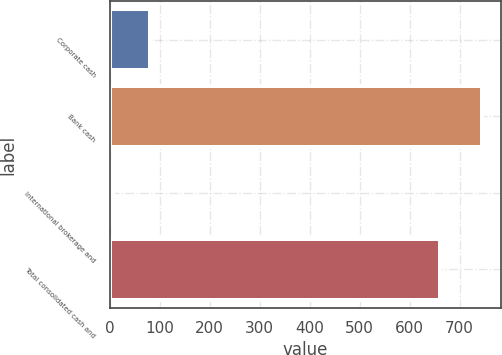Convert chart. <chart><loc_0><loc_0><loc_500><loc_500><bar_chart><fcel>Corporate cash<fcel>Bank cash<fcel>International brokerage and<fcel>Total consolidated cash and<nl><fcel>80.85<fcel>745.5<fcel>7<fcel>661.7<nl></chart> 